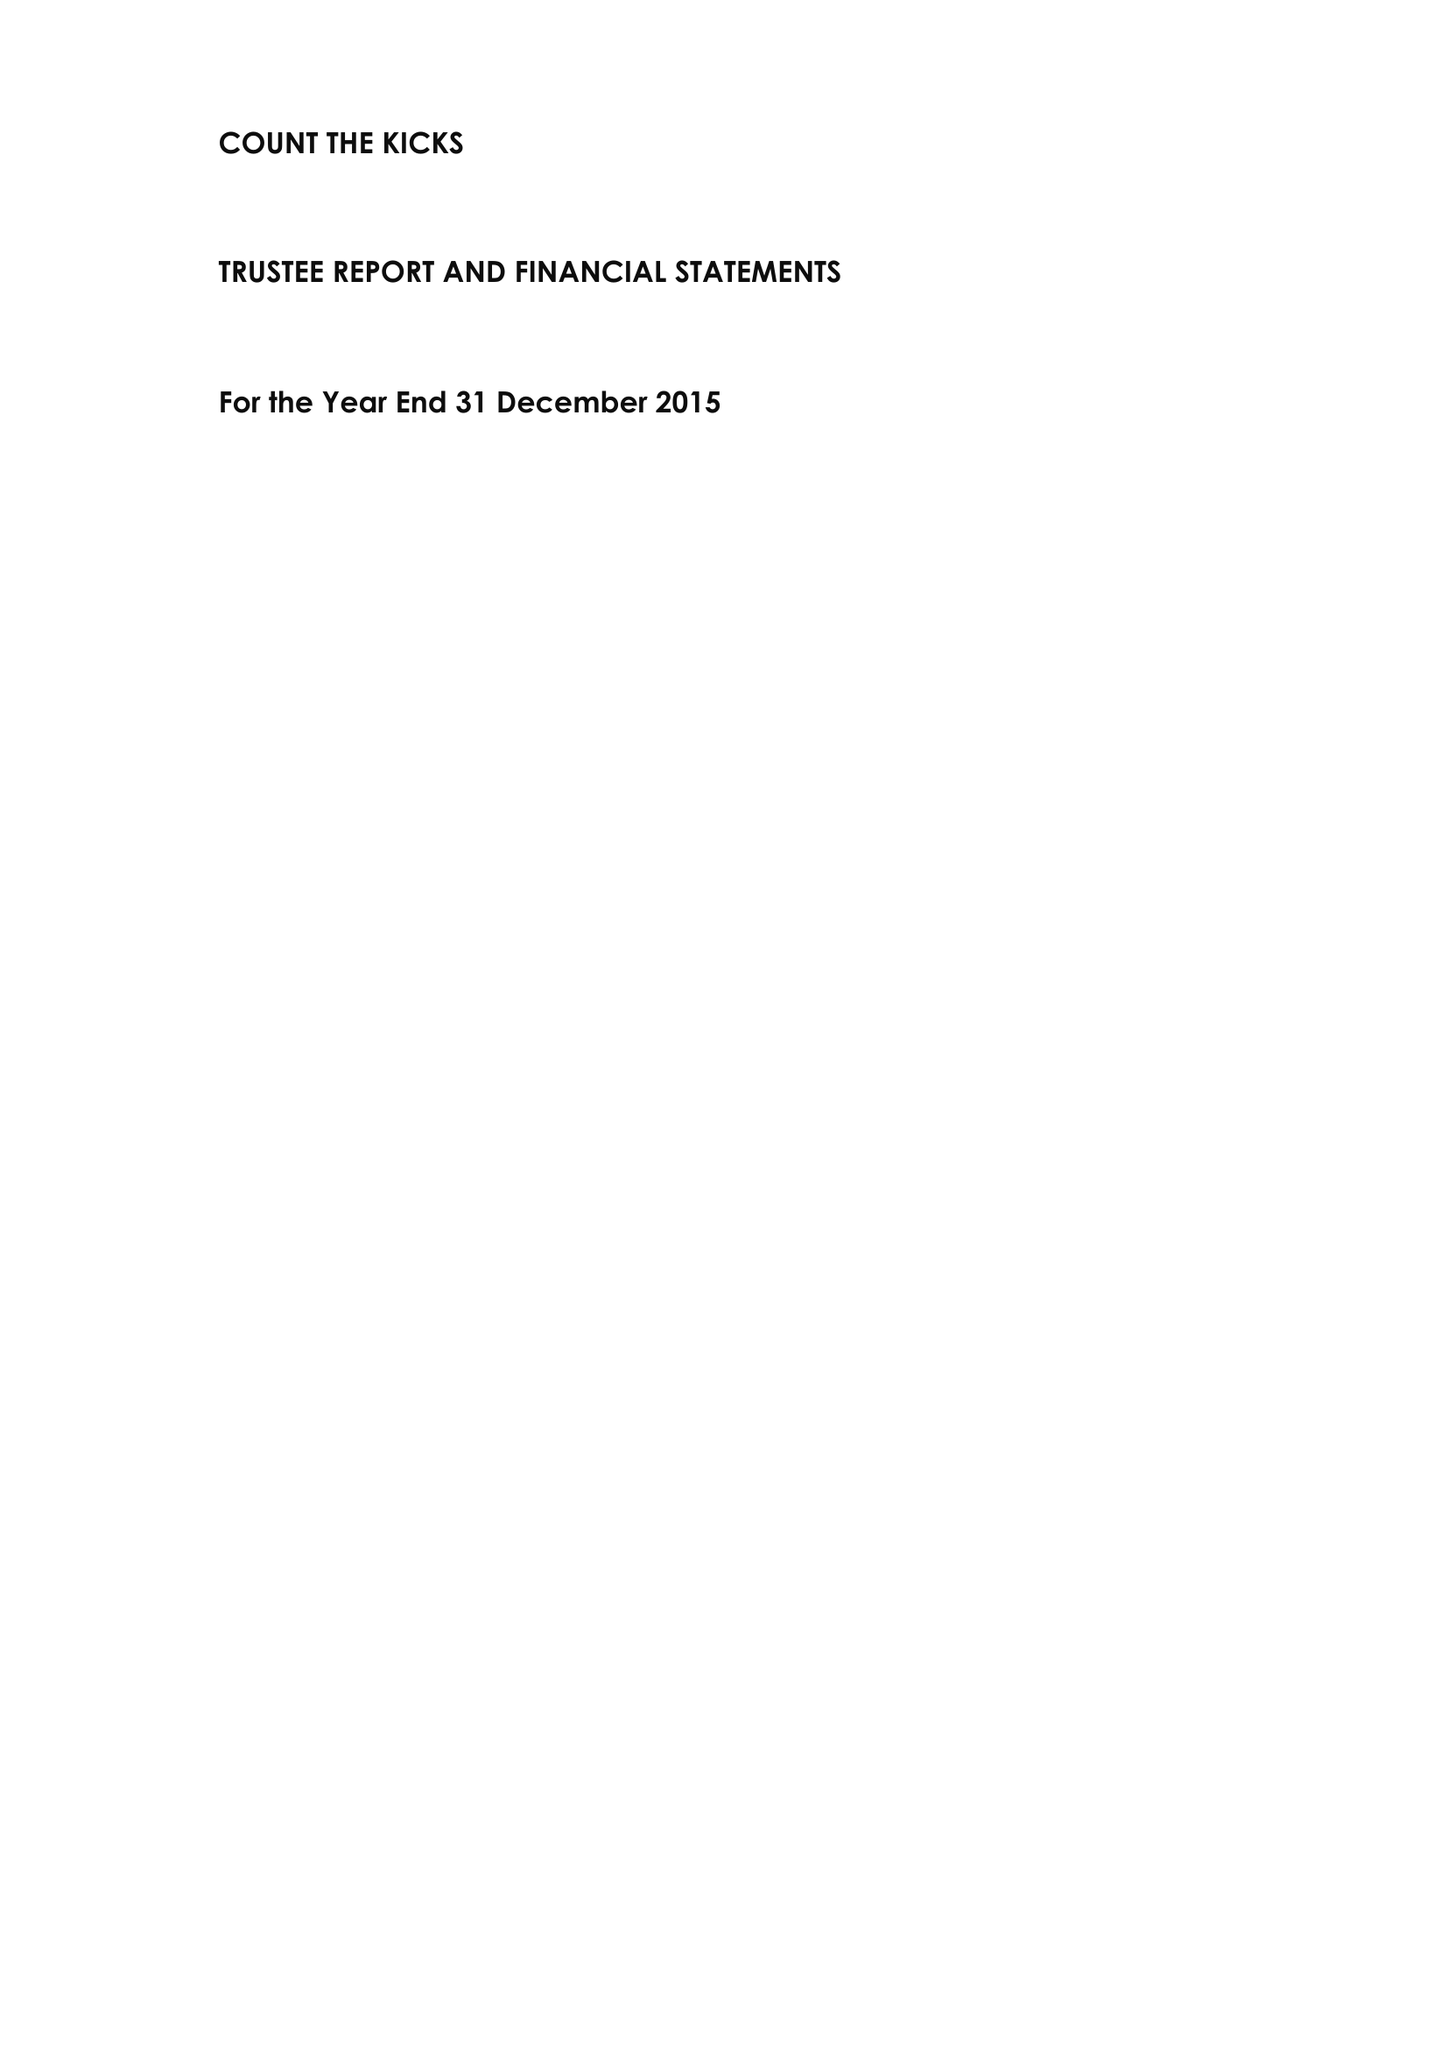What is the value for the charity_name?
Answer the question using a single word or phrase. Kicks Count 